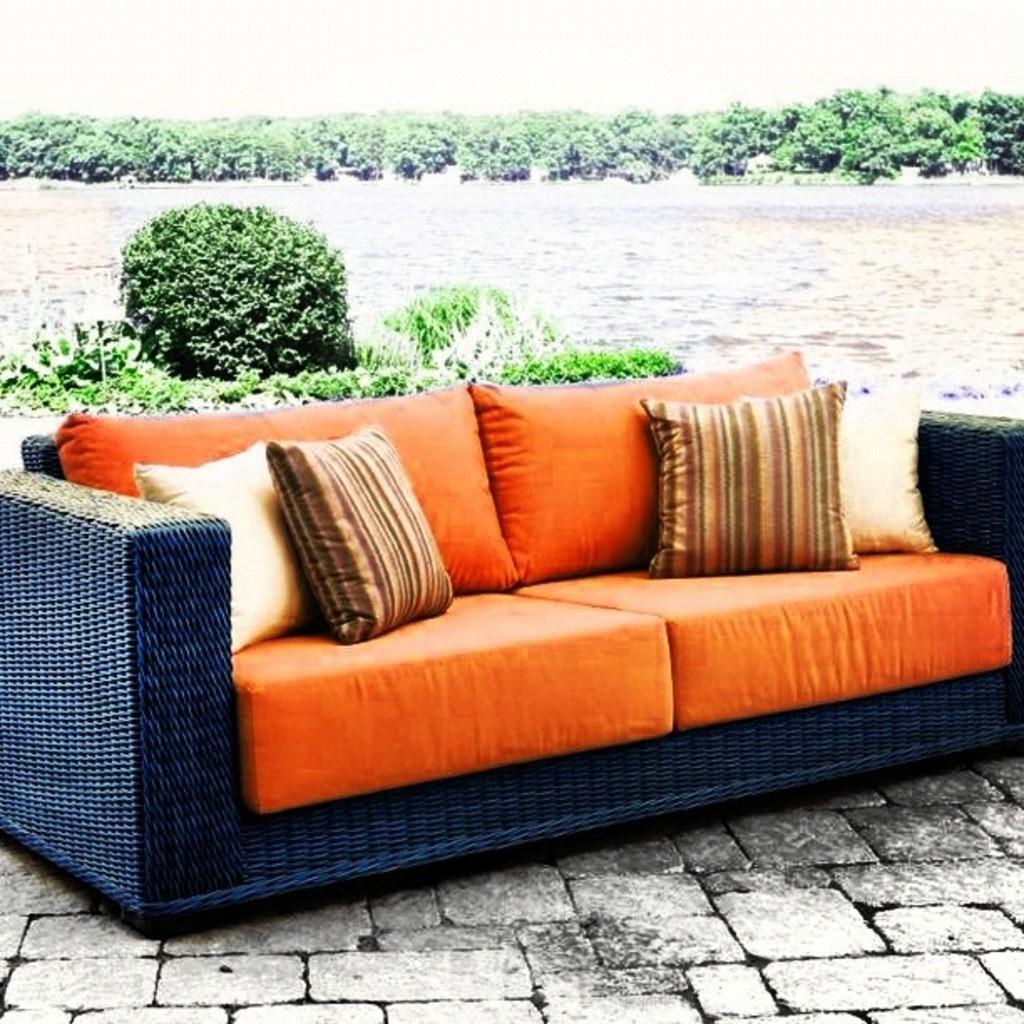Could you give a brief overview of what you see in this image? In this picture we can see sofa and on sofa we have pillows, this is on floor and in background we can see trees, water, sky. 